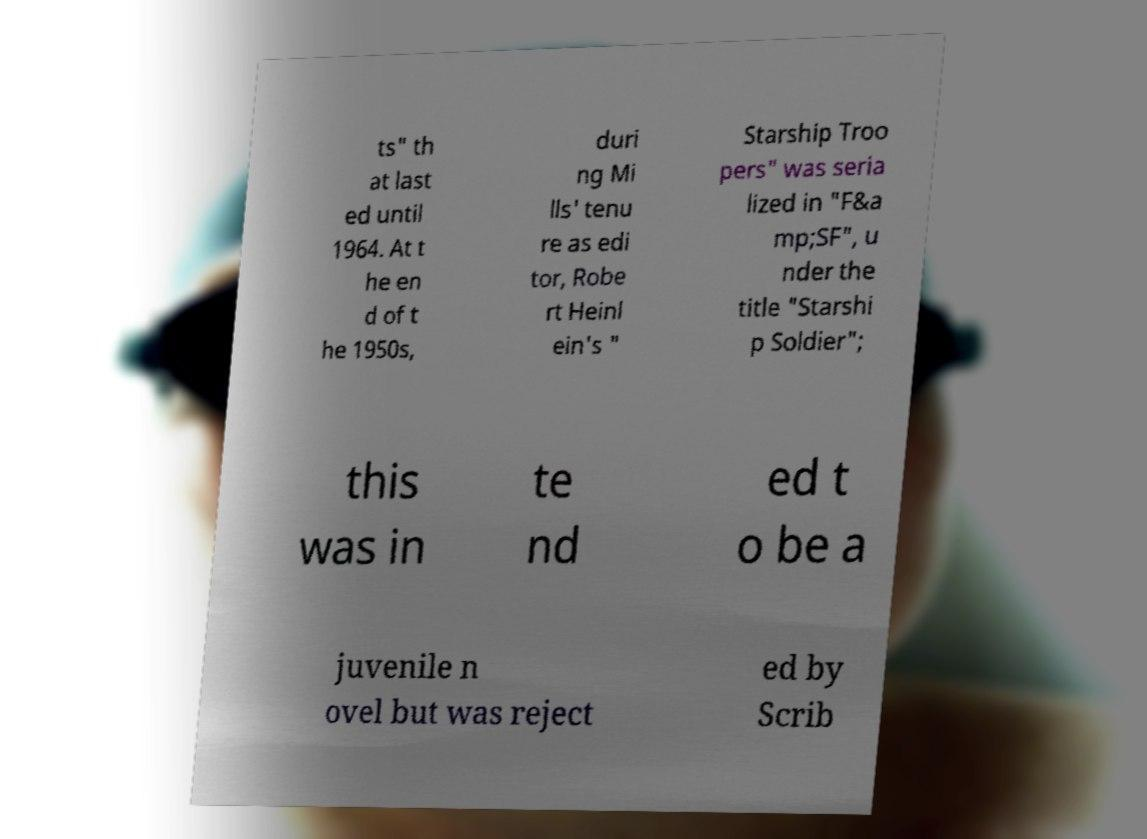Could you assist in decoding the text presented in this image and type it out clearly? ts" th at last ed until 1964. At t he en d of t he 1950s, duri ng Mi lls' tenu re as edi tor, Robe rt Heinl ein's " Starship Troo pers" was seria lized in "F&a mp;SF", u nder the title "Starshi p Soldier"; this was in te nd ed t o be a juvenile n ovel but was reject ed by Scrib 